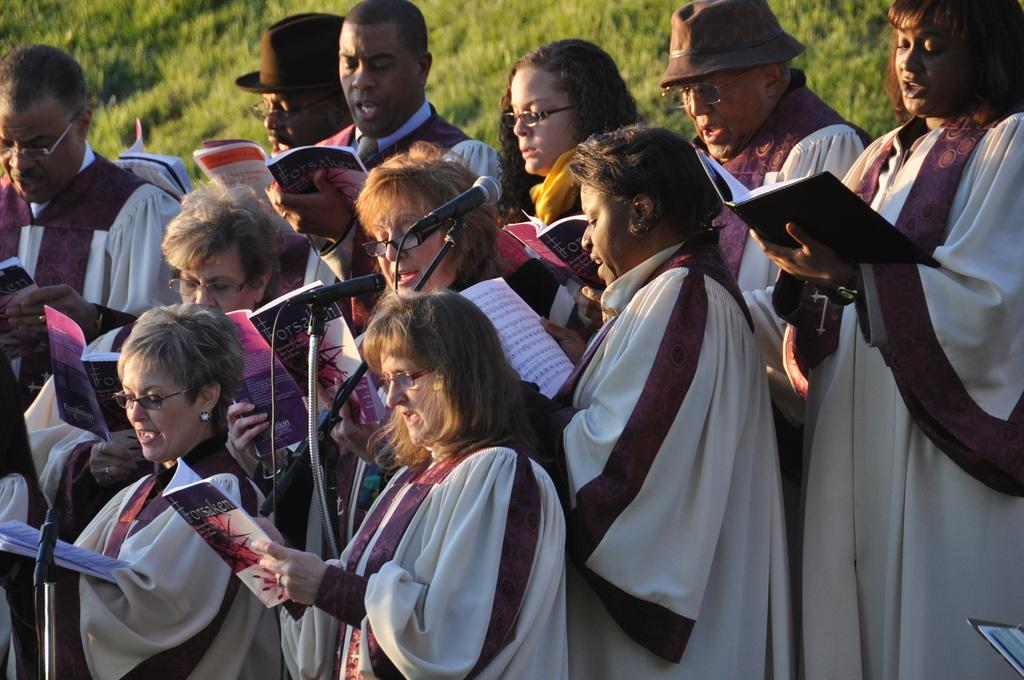How many people are in the image? There is a group of persons in the image. What are the persons wearing? The persons are wearing the same dress. What are the persons holding in the image? The persons are holding books. What objects can be seen in the center of the image? There are two microphones in the center of the image. What can be seen in the background of the image? There is grass visible in the background of the image. How many snakes are slithering around the persons in the image? There are no snakes present in the image; the persons are holding books and there are microphones in the center. 